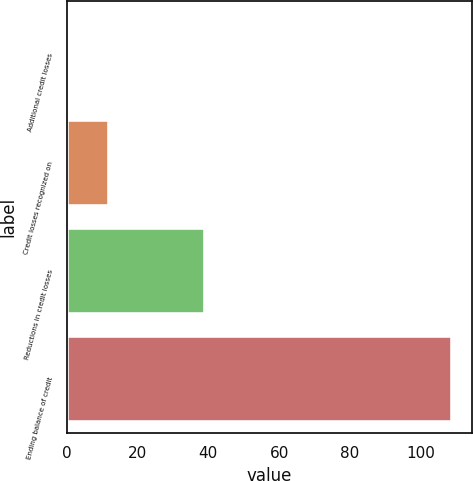Convert chart. <chart><loc_0><loc_0><loc_500><loc_500><bar_chart><fcel>Additional credit losses<fcel>Credit losses recognized on<fcel>Reductions in credit losses<fcel>Ending balance of credit<nl><fcel>1<fcel>11.8<fcel>39<fcel>109<nl></chart> 